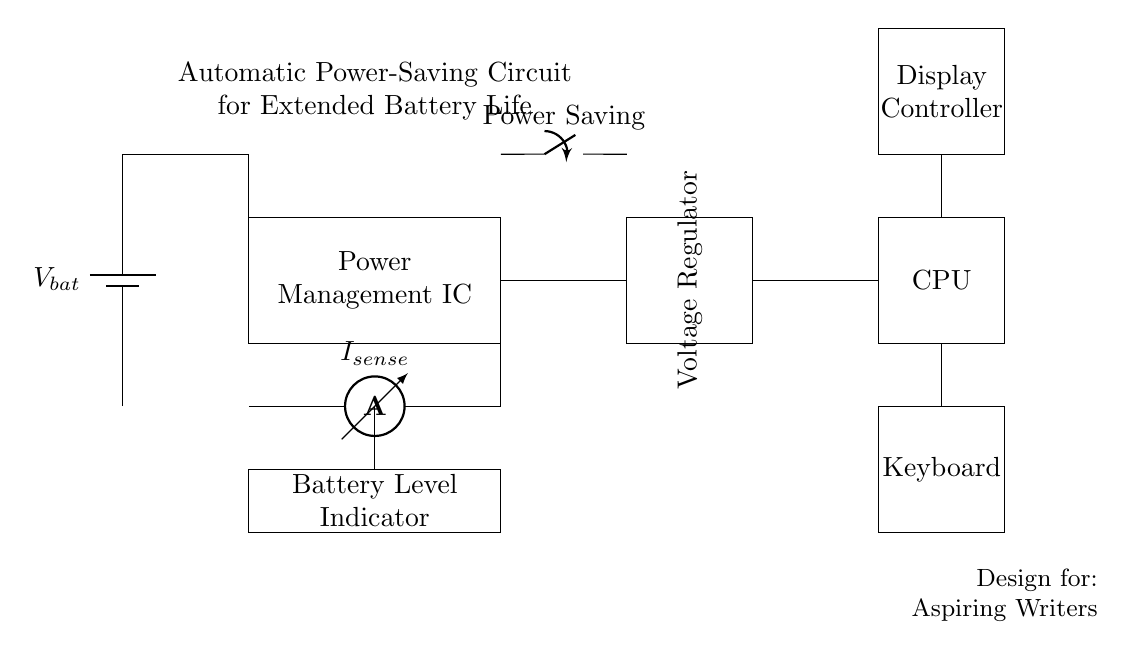What type of circuit is shown? The circuit is an automatic power-saving circuit designed for laptops to help extend battery life during usage. This is evident from the title in the circuit diagram that states its purpose clearly.
Answer: Automatic power-saving circuit What is the main component controlling power distribution? The main component controlling power distribution is the Power Management IC. It is responsible for managing power supply to various components within the circuit, as indicated by its prominent placement.
Answer: Power Management IC What does the ammeter measure in the circuit? The ammeter measures the current flowing through the circuit, specifically the current being drawn by the system. It is positioned between the Power Management IC and the battery to monitor power usage accurately.
Answer: Current What is the function of the voltage regulator in this circuit? The voltage regulator ensures that a constant voltage is supplied to the CPU and other components, regardless of variations in the input voltage or load conditions. This is crucial for maintaining proper operation of sensitive components.
Answer: Constant voltage supply What happens when the power saving switch is activated? When the power saving switch is activated, it redirects power management to implement energy-saving measures, reducing the overall power consumption and extending battery life. This is indicated by its connection to the Power Management IC.
Answer: Reduces power consumption What is the purpose of the battery level indicator? The battery level indicator provides a visual representation of the remaining battery charge level, allowing the user to monitor the battery status during writing sessions. Its placement in the circuit emphasizes its role in managing battery life effectively.
Answer: Battery status monitoring Which components are connected to the voltage regulator? The components connected to the voltage regulator are the CPU and the Display Controller, as shown by the connections emanating from the voltage regulator to these components. This highlights its role in supplying them with necessary voltage.
Answer: CPU and Display Controller 